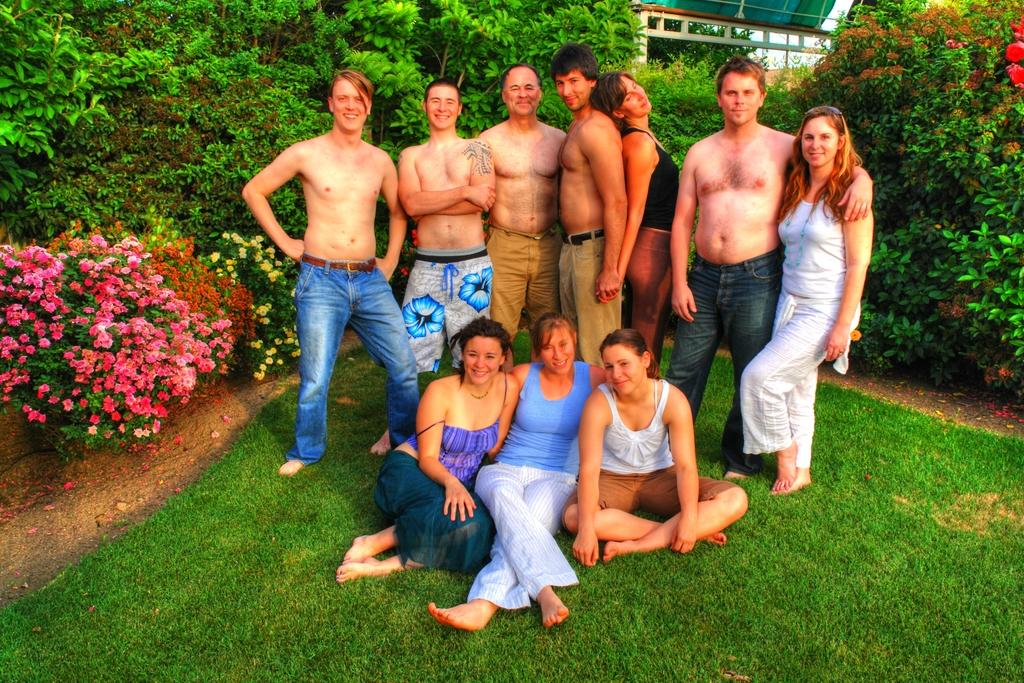What type of location is the image taken in? The image is taken in a garden area. Can you describe the people in the image? There are people standing in the image. How many women are sitting in the image? There are three women sitting in the image. What can be seen in the background of the image? There are trees, flower plants, and a shelter in the background of the image. Are there any steam clouds visible in the image? No, there are no steam clouds present in the image. How does the growth of the flower plants affect the appearance of the women in the image? The growth of the flower plants does not affect the appearance of the women in the image, as they are separate elements in the scene. 